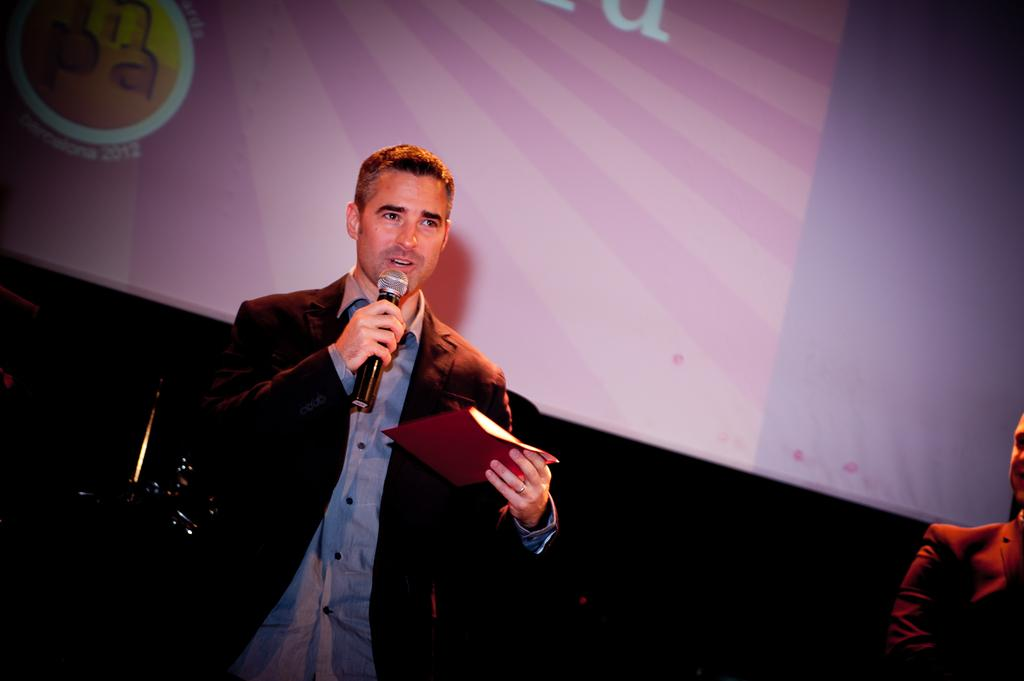What is the man in the image holding? The man is holding a microphone and an object in his hands. What might the man be doing in the image? The man might be giving a presentation or speech, as he is holding a microphone. What is visible in the background of the image? There is a projector screen in the background of the image. Can you describe the person on the right side of the image? There is a person on the right side of the image, but no specific details are provided about them. How much of the trail can be seen in the image? There is no trail present in the image; it features a man holding a microphone and an object, a projector screen in the background, and a person on the right side. 